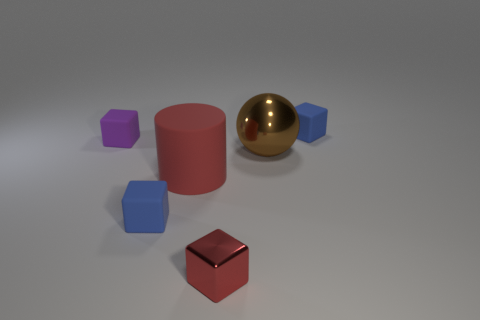Add 3 cylinders. How many objects exist? 9 Subtract all blocks. How many objects are left? 2 Subtract 0 brown cylinders. How many objects are left? 6 Subtract all tiny purple metallic spheres. Subtract all brown metallic objects. How many objects are left? 5 Add 2 large brown things. How many large brown things are left? 3 Add 1 small metallic blocks. How many small metallic blocks exist? 2 